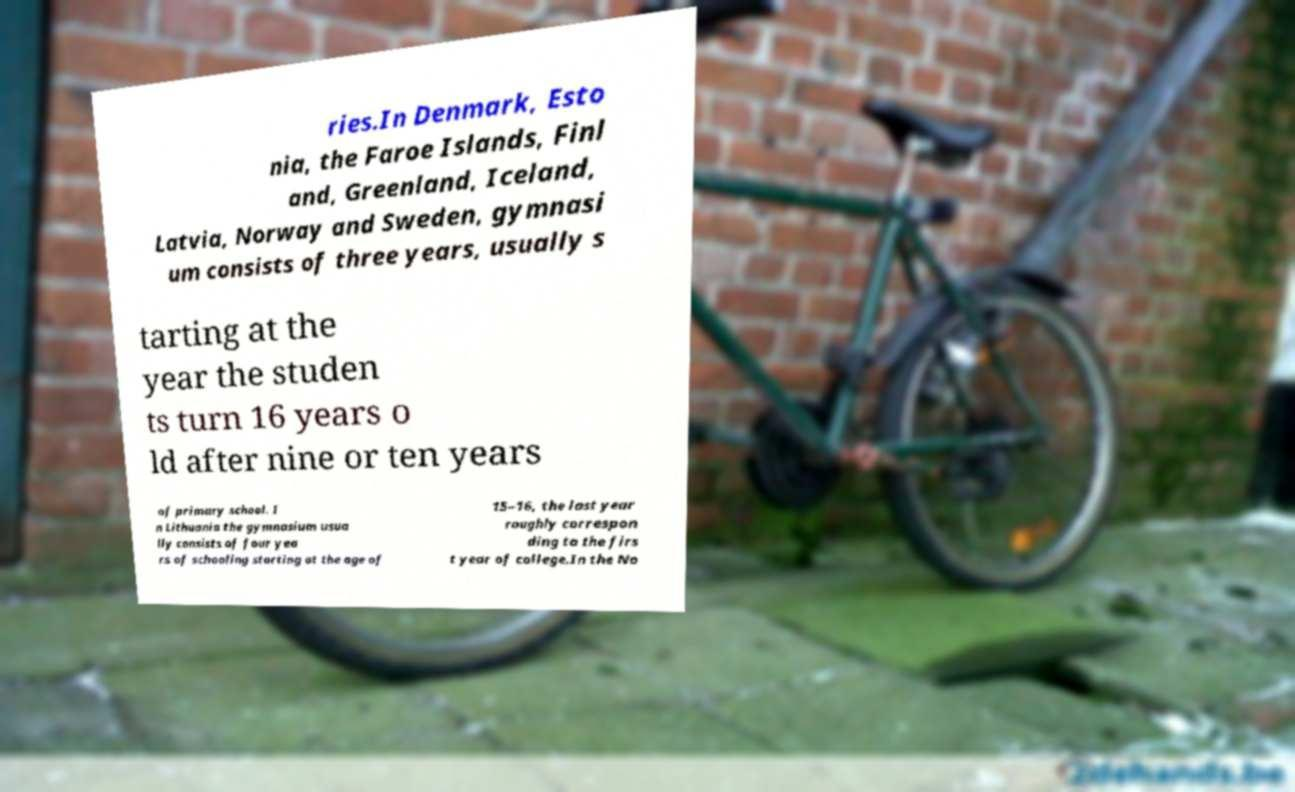What messages or text are displayed in this image? I need them in a readable, typed format. ries.In Denmark, Esto nia, the Faroe Islands, Finl and, Greenland, Iceland, Latvia, Norway and Sweden, gymnasi um consists of three years, usually s tarting at the year the studen ts turn 16 years o ld after nine or ten years of primary school. I n Lithuania the gymnasium usua lly consists of four yea rs of schooling starting at the age of 15–16, the last year roughly correspon ding to the firs t year of college.In the No 